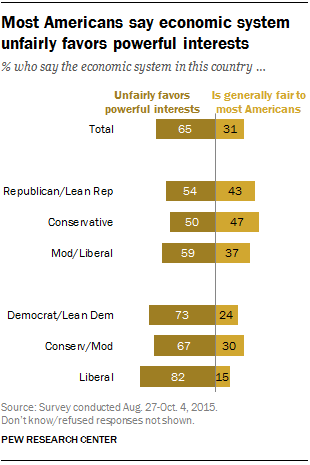Specify some key components in this picture. A recent survey found that 82% of liberals believe that the economic system in this country unfairly favors powerful interests. The ratio (A:B) of the first brown bar from the top and the smallest yellow bar is 2.71875.. 